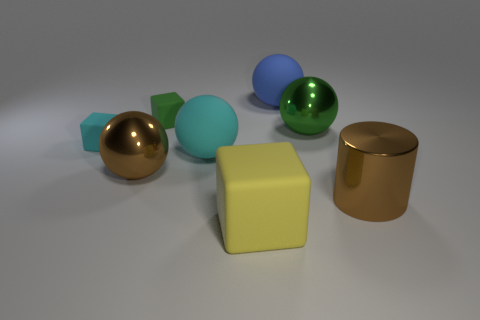What number of big objects are brown rubber balls or rubber balls?
Your answer should be very brief. 2. There is a matte thing that is on the right side of the yellow rubber block; is it the same size as the brown metallic object left of the big block?
Your answer should be compact. Yes. What is the size of the brown metallic thing that is the same shape as the blue object?
Offer a terse response. Large. Is the number of rubber things that are in front of the large shiny cylinder greater than the number of yellow matte objects behind the large cyan object?
Ensure brevity in your answer.  Yes. There is a block that is right of the small cyan thing and behind the brown metallic cylinder; what material is it?
Ensure brevity in your answer.  Rubber. The other large rubber thing that is the same shape as the big blue matte thing is what color?
Offer a very short reply. Cyan. How big is the yellow cube?
Provide a short and direct response. Large. There is a big metallic object that is on the left side of the small object that is behind the tiny cyan rubber block; what is its color?
Your response must be concise. Brown. How many objects are to the right of the green shiny ball and left of the brown metal cylinder?
Ensure brevity in your answer.  0. Is the number of tiny gray cylinders greater than the number of green balls?
Offer a terse response. No. 